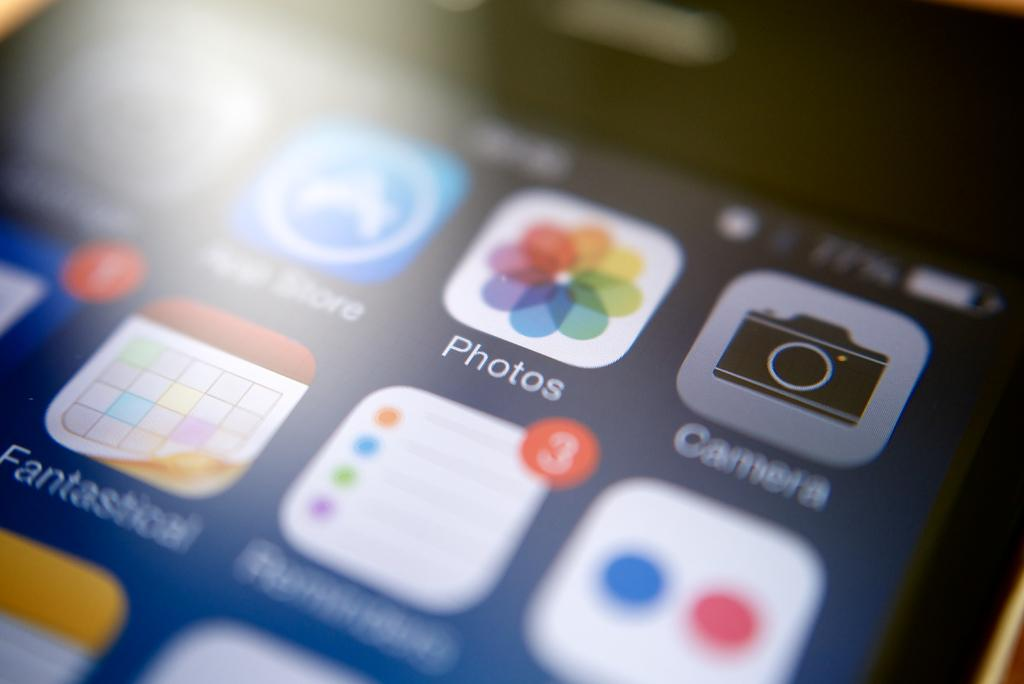<image>
Relay a brief, clear account of the picture shown. The app screen on a phone showing photos and camera icons. 